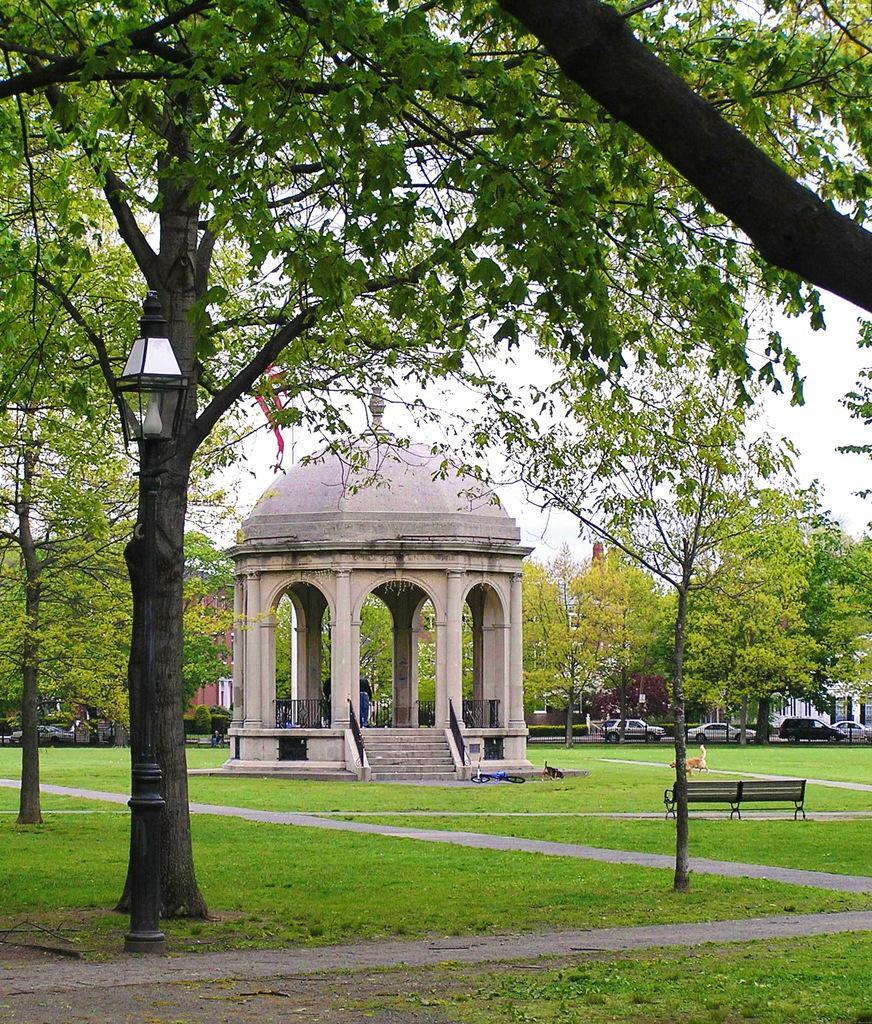Describe this image in one or two sentences. In this image in the middle there are trees, lights, benches, grass, dog, cycle, picnic spot, plants, cars. At the bottom there is land and pole. At the top there is sky. 